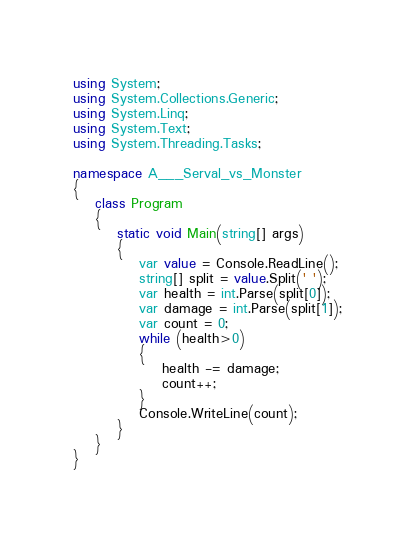Convert code to text. <code><loc_0><loc_0><loc_500><loc_500><_C#_>using System;
using System.Collections.Generic;
using System.Linq;
using System.Text;
using System.Threading.Tasks;

namespace A___Serval_vs_Monster
{
    class Program
    {
        static void Main(string[] args)
        {
            var value = Console.ReadLine();
            string[] split = value.Split(' ');
            var health = int.Parse(split[0]);
            var damage = int.Parse(split[1]);
            var count = 0;
            while (health>0)
            {
                health -= damage;
                count++;
            }
            Console.WriteLine(count);
        }
    }
}
</code> 